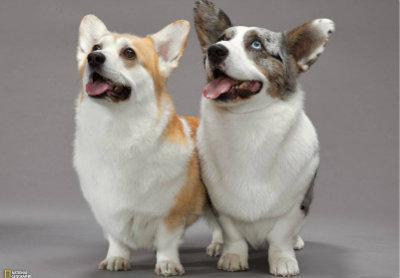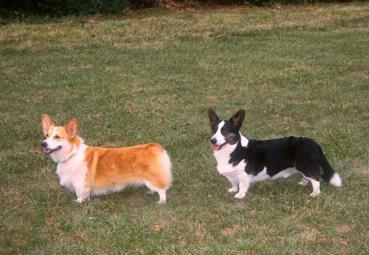The first image is the image on the left, the second image is the image on the right. Analyze the images presented: Is the assertion "An image contains exactly two corgi dogs standing on grass." valid? Answer yes or no. Yes. The first image is the image on the left, the second image is the image on the right. Given the left and right images, does the statement "An image shows a pair of short-legged dogs standing facing forward and posed side-by-side." hold true? Answer yes or no. Yes. 